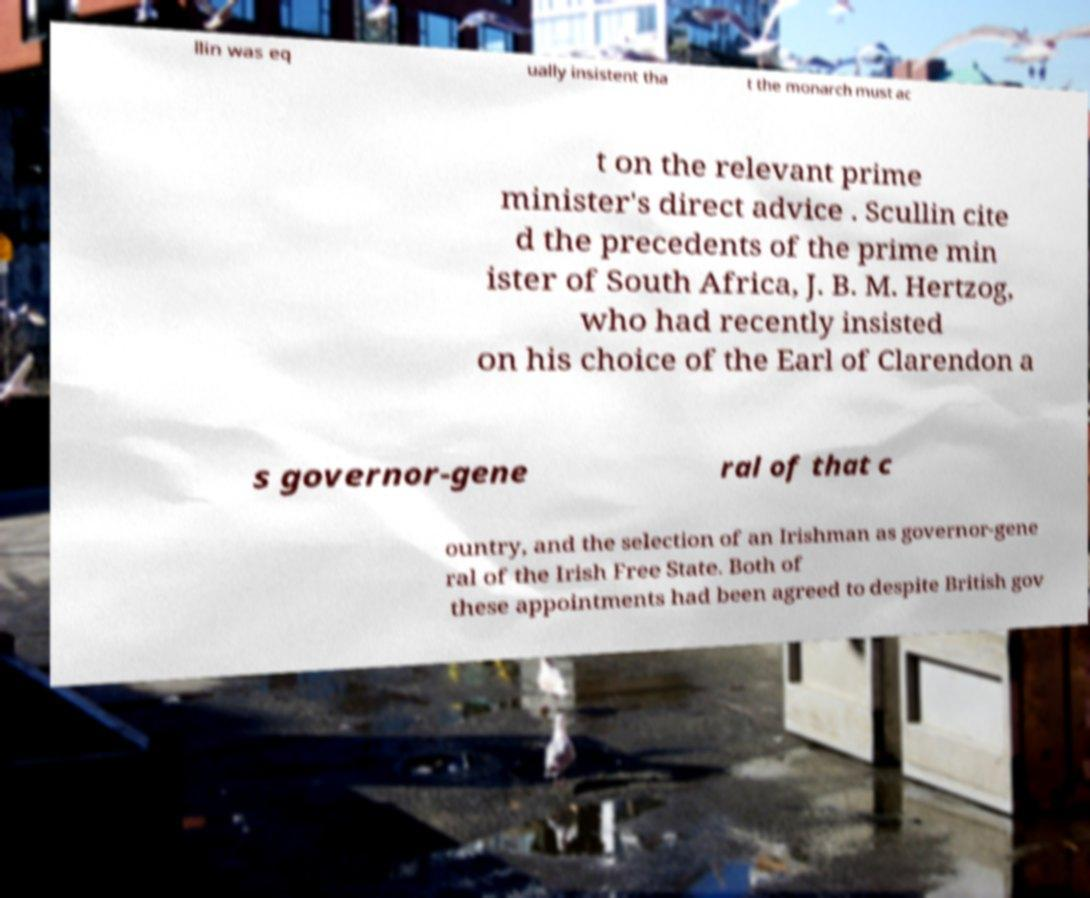I need the written content from this picture converted into text. Can you do that? llin was eq ually insistent tha t the monarch must ac t on the relevant prime minister's direct advice . Scullin cite d the precedents of the prime min ister of South Africa, J. B. M. Hertzog, who had recently insisted on his choice of the Earl of Clarendon a s governor-gene ral of that c ountry, and the selection of an Irishman as governor-gene ral of the Irish Free State. Both of these appointments had been agreed to despite British gov 